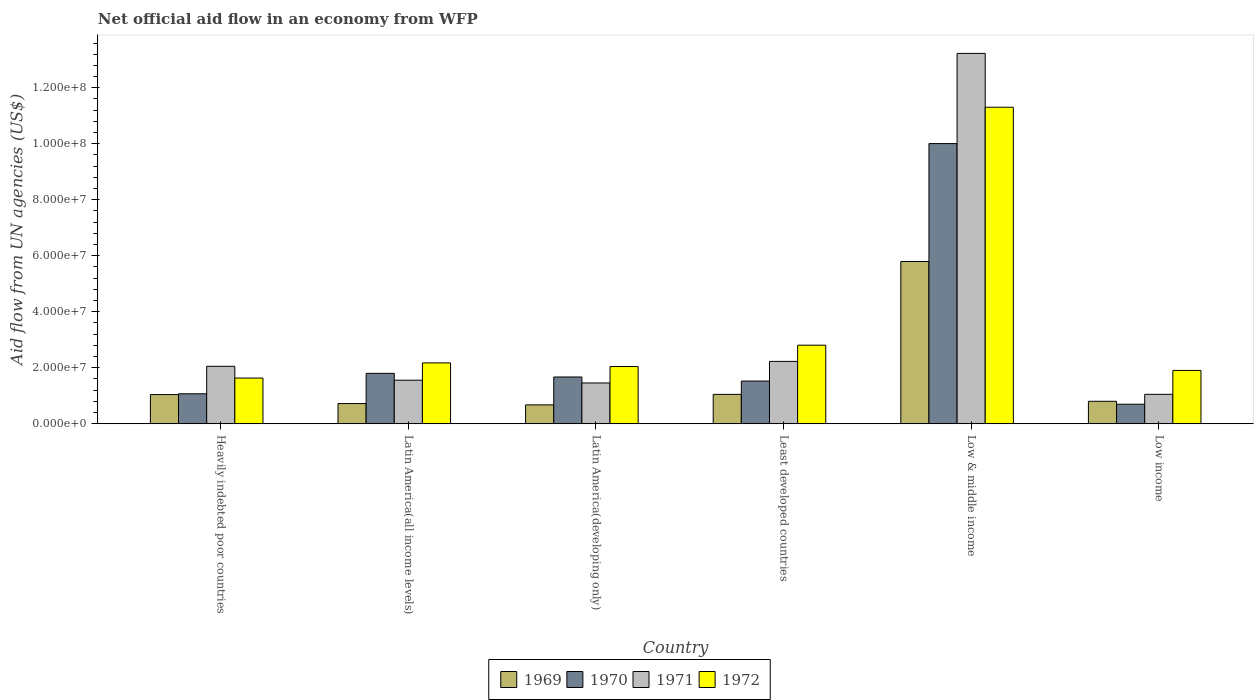Are the number of bars on each tick of the X-axis equal?
Offer a terse response. Yes. How many bars are there on the 2nd tick from the left?
Make the answer very short. 4. How many bars are there on the 4th tick from the right?
Provide a short and direct response. 4. What is the label of the 3rd group of bars from the left?
Ensure brevity in your answer.  Latin America(developing only). In how many cases, is the number of bars for a given country not equal to the number of legend labels?
Make the answer very short. 0. What is the net official aid flow in 1969 in Low & middle income?
Make the answer very short. 5.80e+07. Across all countries, what is the maximum net official aid flow in 1970?
Offer a very short reply. 1.00e+08. Across all countries, what is the minimum net official aid flow in 1972?
Offer a very short reply. 1.63e+07. What is the total net official aid flow in 1970 in the graph?
Give a very brief answer. 1.68e+08. What is the difference between the net official aid flow in 1969 in Heavily indebted poor countries and that in Latin America(all income levels)?
Provide a short and direct response. 3.21e+06. What is the difference between the net official aid flow in 1971 in Latin America(developing only) and the net official aid flow in 1972 in Latin America(all income levels)?
Your answer should be very brief. -7.17e+06. What is the average net official aid flow in 1972 per country?
Offer a very short reply. 3.64e+07. What is the difference between the net official aid flow of/in 1970 and net official aid flow of/in 1972 in Least developed countries?
Provide a succinct answer. -1.28e+07. In how many countries, is the net official aid flow in 1972 greater than 116000000 US$?
Keep it short and to the point. 0. What is the ratio of the net official aid flow in 1972 in Latin America(all income levels) to that in Low income?
Give a very brief answer. 1.14. What is the difference between the highest and the second highest net official aid flow in 1970?
Offer a very short reply. 8.34e+07. What is the difference between the highest and the lowest net official aid flow in 1969?
Your response must be concise. 5.12e+07. Is it the case that in every country, the sum of the net official aid flow in 1970 and net official aid flow in 1972 is greater than the sum of net official aid flow in 1969 and net official aid flow in 1971?
Your answer should be very brief. No. What does the 3rd bar from the left in Latin America(developing only) represents?
Give a very brief answer. 1971. What does the 4th bar from the right in Latin America(all income levels) represents?
Provide a short and direct response. 1969. How many bars are there?
Your answer should be very brief. 24. Are all the bars in the graph horizontal?
Your answer should be compact. No. What is the difference between two consecutive major ticks on the Y-axis?
Give a very brief answer. 2.00e+07. Are the values on the major ticks of Y-axis written in scientific E-notation?
Your response must be concise. Yes. Does the graph contain grids?
Offer a very short reply. No. What is the title of the graph?
Your response must be concise. Net official aid flow in an economy from WFP. Does "1971" appear as one of the legend labels in the graph?
Make the answer very short. Yes. What is the label or title of the Y-axis?
Make the answer very short. Aid flow from UN agencies (US$). What is the Aid flow from UN agencies (US$) of 1969 in Heavily indebted poor countries?
Provide a succinct answer. 1.04e+07. What is the Aid flow from UN agencies (US$) of 1970 in Heavily indebted poor countries?
Your response must be concise. 1.07e+07. What is the Aid flow from UN agencies (US$) in 1971 in Heavily indebted poor countries?
Your answer should be very brief. 2.05e+07. What is the Aid flow from UN agencies (US$) in 1972 in Heavily indebted poor countries?
Your answer should be compact. 1.63e+07. What is the Aid flow from UN agencies (US$) of 1969 in Latin America(all income levels)?
Your answer should be very brief. 7.21e+06. What is the Aid flow from UN agencies (US$) in 1970 in Latin America(all income levels)?
Provide a short and direct response. 1.80e+07. What is the Aid flow from UN agencies (US$) of 1971 in Latin America(all income levels)?
Offer a terse response. 1.56e+07. What is the Aid flow from UN agencies (US$) in 1972 in Latin America(all income levels)?
Give a very brief answer. 2.17e+07. What is the Aid flow from UN agencies (US$) in 1969 in Latin America(developing only)?
Your response must be concise. 6.74e+06. What is the Aid flow from UN agencies (US$) in 1970 in Latin America(developing only)?
Provide a succinct answer. 1.67e+07. What is the Aid flow from UN agencies (US$) of 1971 in Latin America(developing only)?
Make the answer very short. 1.46e+07. What is the Aid flow from UN agencies (US$) of 1972 in Latin America(developing only)?
Your answer should be very brief. 2.04e+07. What is the Aid flow from UN agencies (US$) of 1969 in Least developed countries?
Give a very brief answer. 1.05e+07. What is the Aid flow from UN agencies (US$) in 1970 in Least developed countries?
Ensure brevity in your answer.  1.52e+07. What is the Aid flow from UN agencies (US$) in 1971 in Least developed countries?
Your response must be concise. 2.23e+07. What is the Aid flow from UN agencies (US$) in 1972 in Least developed countries?
Provide a succinct answer. 2.81e+07. What is the Aid flow from UN agencies (US$) in 1969 in Low & middle income?
Your response must be concise. 5.80e+07. What is the Aid flow from UN agencies (US$) of 1970 in Low & middle income?
Your answer should be compact. 1.00e+08. What is the Aid flow from UN agencies (US$) in 1971 in Low & middle income?
Keep it short and to the point. 1.32e+08. What is the Aid flow from UN agencies (US$) in 1972 in Low & middle income?
Ensure brevity in your answer.  1.13e+08. What is the Aid flow from UN agencies (US$) in 1969 in Low income?
Give a very brief answer. 8.02e+06. What is the Aid flow from UN agencies (US$) of 1970 in Low income?
Ensure brevity in your answer.  6.97e+06. What is the Aid flow from UN agencies (US$) in 1971 in Low income?
Give a very brief answer. 1.05e+07. What is the Aid flow from UN agencies (US$) in 1972 in Low income?
Provide a short and direct response. 1.90e+07. Across all countries, what is the maximum Aid flow from UN agencies (US$) of 1969?
Give a very brief answer. 5.80e+07. Across all countries, what is the maximum Aid flow from UN agencies (US$) of 1970?
Ensure brevity in your answer.  1.00e+08. Across all countries, what is the maximum Aid flow from UN agencies (US$) in 1971?
Provide a short and direct response. 1.32e+08. Across all countries, what is the maximum Aid flow from UN agencies (US$) of 1972?
Offer a very short reply. 1.13e+08. Across all countries, what is the minimum Aid flow from UN agencies (US$) of 1969?
Your answer should be compact. 6.74e+06. Across all countries, what is the minimum Aid flow from UN agencies (US$) in 1970?
Offer a terse response. 6.97e+06. Across all countries, what is the minimum Aid flow from UN agencies (US$) in 1971?
Provide a succinct answer. 1.05e+07. Across all countries, what is the minimum Aid flow from UN agencies (US$) in 1972?
Offer a very short reply. 1.63e+07. What is the total Aid flow from UN agencies (US$) in 1969 in the graph?
Give a very brief answer. 1.01e+08. What is the total Aid flow from UN agencies (US$) of 1970 in the graph?
Your response must be concise. 1.68e+08. What is the total Aid flow from UN agencies (US$) in 1971 in the graph?
Your answer should be compact. 2.16e+08. What is the total Aid flow from UN agencies (US$) in 1972 in the graph?
Ensure brevity in your answer.  2.19e+08. What is the difference between the Aid flow from UN agencies (US$) of 1969 in Heavily indebted poor countries and that in Latin America(all income levels)?
Your response must be concise. 3.21e+06. What is the difference between the Aid flow from UN agencies (US$) of 1970 in Heavily indebted poor countries and that in Latin America(all income levels)?
Ensure brevity in your answer.  -7.30e+06. What is the difference between the Aid flow from UN agencies (US$) of 1971 in Heavily indebted poor countries and that in Latin America(all income levels)?
Ensure brevity in your answer.  4.97e+06. What is the difference between the Aid flow from UN agencies (US$) of 1972 in Heavily indebted poor countries and that in Latin America(all income levels)?
Provide a succinct answer. -5.41e+06. What is the difference between the Aid flow from UN agencies (US$) of 1969 in Heavily indebted poor countries and that in Latin America(developing only)?
Keep it short and to the point. 3.68e+06. What is the difference between the Aid flow from UN agencies (US$) of 1970 in Heavily indebted poor countries and that in Latin America(developing only)?
Your response must be concise. -6.00e+06. What is the difference between the Aid flow from UN agencies (US$) in 1971 in Heavily indebted poor countries and that in Latin America(developing only)?
Provide a succinct answer. 5.96e+06. What is the difference between the Aid flow from UN agencies (US$) in 1972 in Heavily indebted poor countries and that in Latin America(developing only)?
Your answer should be very brief. -4.11e+06. What is the difference between the Aid flow from UN agencies (US$) of 1969 in Heavily indebted poor countries and that in Least developed countries?
Give a very brief answer. -7.00e+04. What is the difference between the Aid flow from UN agencies (US$) in 1970 in Heavily indebted poor countries and that in Least developed countries?
Keep it short and to the point. -4.54e+06. What is the difference between the Aid flow from UN agencies (US$) in 1971 in Heavily indebted poor countries and that in Least developed countries?
Your response must be concise. -1.75e+06. What is the difference between the Aid flow from UN agencies (US$) of 1972 in Heavily indebted poor countries and that in Least developed countries?
Offer a terse response. -1.17e+07. What is the difference between the Aid flow from UN agencies (US$) of 1969 in Heavily indebted poor countries and that in Low & middle income?
Your answer should be very brief. -4.75e+07. What is the difference between the Aid flow from UN agencies (US$) of 1970 in Heavily indebted poor countries and that in Low & middle income?
Offer a very short reply. -8.94e+07. What is the difference between the Aid flow from UN agencies (US$) of 1971 in Heavily indebted poor countries and that in Low & middle income?
Give a very brief answer. -1.12e+08. What is the difference between the Aid flow from UN agencies (US$) of 1972 in Heavily indebted poor countries and that in Low & middle income?
Give a very brief answer. -9.67e+07. What is the difference between the Aid flow from UN agencies (US$) in 1969 in Heavily indebted poor countries and that in Low income?
Offer a terse response. 2.40e+06. What is the difference between the Aid flow from UN agencies (US$) of 1970 in Heavily indebted poor countries and that in Low income?
Give a very brief answer. 3.73e+06. What is the difference between the Aid flow from UN agencies (US$) in 1971 in Heavily indebted poor countries and that in Low income?
Provide a succinct answer. 1.00e+07. What is the difference between the Aid flow from UN agencies (US$) of 1972 in Heavily indebted poor countries and that in Low income?
Ensure brevity in your answer.  -2.72e+06. What is the difference between the Aid flow from UN agencies (US$) in 1969 in Latin America(all income levels) and that in Latin America(developing only)?
Make the answer very short. 4.70e+05. What is the difference between the Aid flow from UN agencies (US$) of 1970 in Latin America(all income levels) and that in Latin America(developing only)?
Offer a very short reply. 1.30e+06. What is the difference between the Aid flow from UN agencies (US$) of 1971 in Latin America(all income levels) and that in Latin America(developing only)?
Your answer should be very brief. 9.90e+05. What is the difference between the Aid flow from UN agencies (US$) in 1972 in Latin America(all income levels) and that in Latin America(developing only)?
Offer a very short reply. 1.30e+06. What is the difference between the Aid flow from UN agencies (US$) in 1969 in Latin America(all income levels) and that in Least developed countries?
Your answer should be compact. -3.28e+06. What is the difference between the Aid flow from UN agencies (US$) in 1970 in Latin America(all income levels) and that in Least developed countries?
Your answer should be compact. 2.76e+06. What is the difference between the Aid flow from UN agencies (US$) in 1971 in Latin America(all income levels) and that in Least developed countries?
Provide a succinct answer. -6.72e+06. What is the difference between the Aid flow from UN agencies (US$) of 1972 in Latin America(all income levels) and that in Least developed countries?
Offer a terse response. -6.33e+06. What is the difference between the Aid flow from UN agencies (US$) of 1969 in Latin America(all income levels) and that in Low & middle income?
Provide a succinct answer. -5.08e+07. What is the difference between the Aid flow from UN agencies (US$) of 1970 in Latin America(all income levels) and that in Low & middle income?
Provide a short and direct response. -8.21e+07. What is the difference between the Aid flow from UN agencies (US$) of 1971 in Latin America(all income levels) and that in Low & middle income?
Your answer should be compact. -1.17e+08. What is the difference between the Aid flow from UN agencies (US$) in 1972 in Latin America(all income levels) and that in Low & middle income?
Your answer should be compact. -9.13e+07. What is the difference between the Aid flow from UN agencies (US$) of 1969 in Latin America(all income levels) and that in Low income?
Keep it short and to the point. -8.10e+05. What is the difference between the Aid flow from UN agencies (US$) of 1970 in Latin America(all income levels) and that in Low income?
Your response must be concise. 1.10e+07. What is the difference between the Aid flow from UN agencies (US$) in 1971 in Latin America(all income levels) and that in Low income?
Keep it short and to the point. 5.04e+06. What is the difference between the Aid flow from UN agencies (US$) of 1972 in Latin America(all income levels) and that in Low income?
Offer a very short reply. 2.69e+06. What is the difference between the Aid flow from UN agencies (US$) of 1969 in Latin America(developing only) and that in Least developed countries?
Provide a short and direct response. -3.75e+06. What is the difference between the Aid flow from UN agencies (US$) of 1970 in Latin America(developing only) and that in Least developed countries?
Give a very brief answer. 1.46e+06. What is the difference between the Aid flow from UN agencies (US$) of 1971 in Latin America(developing only) and that in Least developed countries?
Provide a succinct answer. -7.71e+06. What is the difference between the Aid flow from UN agencies (US$) in 1972 in Latin America(developing only) and that in Least developed countries?
Provide a short and direct response. -7.63e+06. What is the difference between the Aid flow from UN agencies (US$) in 1969 in Latin America(developing only) and that in Low & middle income?
Offer a terse response. -5.12e+07. What is the difference between the Aid flow from UN agencies (US$) in 1970 in Latin America(developing only) and that in Low & middle income?
Provide a succinct answer. -8.34e+07. What is the difference between the Aid flow from UN agencies (US$) in 1971 in Latin America(developing only) and that in Low & middle income?
Make the answer very short. -1.18e+08. What is the difference between the Aid flow from UN agencies (US$) of 1972 in Latin America(developing only) and that in Low & middle income?
Your response must be concise. -9.26e+07. What is the difference between the Aid flow from UN agencies (US$) in 1969 in Latin America(developing only) and that in Low income?
Your answer should be very brief. -1.28e+06. What is the difference between the Aid flow from UN agencies (US$) in 1970 in Latin America(developing only) and that in Low income?
Your answer should be compact. 9.73e+06. What is the difference between the Aid flow from UN agencies (US$) in 1971 in Latin America(developing only) and that in Low income?
Keep it short and to the point. 4.05e+06. What is the difference between the Aid flow from UN agencies (US$) of 1972 in Latin America(developing only) and that in Low income?
Your answer should be very brief. 1.39e+06. What is the difference between the Aid flow from UN agencies (US$) in 1969 in Least developed countries and that in Low & middle income?
Your answer should be compact. -4.75e+07. What is the difference between the Aid flow from UN agencies (US$) in 1970 in Least developed countries and that in Low & middle income?
Your answer should be compact. -8.48e+07. What is the difference between the Aid flow from UN agencies (US$) of 1971 in Least developed countries and that in Low & middle income?
Ensure brevity in your answer.  -1.10e+08. What is the difference between the Aid flow from UN agencies (US$) in 1972 in Least developed countries and that in Low & middle income?
Ensure brevity in your answer.  -8.50e+07. What is the difference between the Aid flow from UN agencies (US$) in 1969 in Least developed countries and that in Low income?
Provide a succinct answer. 2.47e+06. What is the difference between the Aid flow from UN agencies (US$) of 1970 in Least developed countries and that in Low income?
Make the answer very short. 8.27e+06. What is the difference between the Aid flow from UN agencies (US$) in 1971 in Least developed countries and that in Low income?
Offer a terse response. 1.18e+07. What is the difference between the Aid flow from UN agencies (US$) in 1972 in Least developed countries and that in Low income?
Provide a short and direct response. 9.02e+06. What is the difference between the Aid flow from UN agencies (US$) of 1969 in Low & middle income and that in Low income?
Ensure brevity in your answer.  4.99e+07. What is the difference between the Aid flow from UN agencies (US$) in 1970 in Low & middle income and that in Low income?
Your response must be concise. 9.31e+07. What is the difference between the Aid flow from UN agencies (US$) in 1971 in Low & middle income and that in Low income?
Provide a succinct answer. 1.22e+08. What is the difference between the Aid flow from UN agencies (US$) of 1972 in Low & middle income and that in Low income?
Ensure brevity in your answer.  9.40e+07. What is the difference between the Aid flow from UN agencies (US$) in 1969 in Heavily indebted poor countries and the Aid flow from UN agencies (US$) in 1970 in Latin America(all income levels)?
Your answer should be very brief. -7.58e+06. What is the difference between the Aid flow from UN agencies (US$) of 1969 in Heavily indebted poor countries and the Aid flow from UN agencies (US$) of 1971 in Latin America(all income levels)?
Offer a terse response. -5.13e+06. What is the difference between the Aid flow from UN agencies (US$) in 1969 in Heavily indebted poor countries and the Aid flow from UN agencies (US$) in 1972 in Latin America(all income levels)?
Offer a terse response. -1.13e+07. What is the difference between the Aid flow from UN agencies (US$) of 1970 in Heavily indebted poor countries and the Aid flow from UN agencies (US$) of 1971 in Latin America(all income levels)?
Provide a short and direct response. -4.85e+06. What is the difference between the Aid flow from UN agencies (US$) of 1970 in Heavily indebted poor countries and the Aid flow from UN agencies (US$) of 1972 in Latin America(all income levels)?
Offer a very short reply. -1.10e+07. What is the difference between the Aid flow from UN agencies (US$) in 1971 in Heavily indebted poor countries and the Aid flow from UN agencies (US$) in 1972 in Latin America(all income levels)?
Offer a terse response. -1.21e+06. What is the difference between the Aid flow from UN agencies (US$) in 1969 in Heavily indebted poor countries and the Aid flow from UN agencies (US$) in 1970 in Latin America(developing only)?
Provide a succinct answer. -6.28e+06. What is the difference between the Aid flow from UN agencies (US$) of 1969 in Heavily indebted poor countries and the Aid flow from UN agencies (US$) of 1971 in Latin America(developing only)?
Provide a short and direct response. -4.14e+06. What is the difference between the Aid flow from UN agencies (US$) of 1969 in Heavily indebted poor countries and the Aid flow from UN agencies (US$) of 1972 in Latin America(developing only)?
Offer a terse response. -1.00e+07. What is the difference between the Aid flow from UN agencies (US$) of 1970 in Heavily indebted poor countries and the Aid flow from UN agencies (US$) of 1971 in Latin America(developing only)?
Your response must be concise. -3.86e+06. What is the difference between the Aid flow from UN agencies (US$) in 1970 in Heavily indebted poor countries and the Aid flow from UN agencies (US$) in 1972 in Latin America(developing only)?
Provide a succinct answer. -9.73e+06. What is the difference between the Aid flow from UN agencies (US$) in 1969 in Heavily indebted poor countries and the Aid flow from UN agencies (US$) in 1970 in Least developed countries?
Your answer should be compact. -4.82e+06. What is the difference between the Aid flow from UN agencies (US$) of 1969 in Heavily indebted poor countries and the Aid flow from UN agencies (US$) of 1971 in Least developed countries?
Provide a short and direct response. -1.18e+07. What is the difference between the Aid flow from UN agencies (US$) in 1969 in Heavily indebted poor countries and the Aid flow from UN agencies (US$) in 1972 in Least developed countries?
Keep it short and to the point. -1.76e+07. What is the difference between the Aid flow from UN agencies (US$) in 1970 in Heavily indebted poor countries and the Aid flow from UN agencies (US$) in 1971 in Least developed countries?
Offer a terse response. -1.16e+07. What is the difference between the Aid flow from UN agencies (US$) of 1970 in Heavily indebted poor countries and the Aid flow from UN agencies (US$) of 1972 in Least developed countries?
Your answer should be very brief. -1.74e+07. What is the difference between the Aid flow from UN agencies (US$) in 1971 in Heavily indebted poor countries and the Aid flow from UN agencies (US$) in 1972 in Least developed countries?
Provide a short and direct response. -7.54e+06. What is the difference between the Aid flow from UN agencies (US$) in 1969 in Heavily indebted poor countries and the Aid flow from UN agencies (US$) in 1970 in Low & middle income?
Your answer should be very brief. -8.96e+07. What is the difference between the Aid flow from UN agencies (US$) in 1969 in Heavily indebted poor countries and the Aid flow from UN agencies (US$) in 1971 in Low & middle income?
Your answer should be compact. -1.22e+08. What is the difference between the Aid flow from UN agencies (US$) in 1969 in Heavily indebted poor countries and the Aid flow from UN agencies (US$) in 1972 in Low & middle income?
Keep it short and to the point. -1.03e+08. What is the difference between the Aid flow from UN agencies (US$) of 1970 in Heavily indebted poor countries and the Aid flow from UN agencies (US$) of 1971 in Low & middle income?
Your answer should be very brief. -1.22e+08. What is the difference between the Aid flow from UN agencies (US$) of 1970 in Heavily indebted poor countries and the Aid flow from UN agencies (US$) of 1972 in Low & middle income?
Offer a terse response. -1.02e+08. What is the difference between the Aid flow from UN agencies (US$) in 1971 in Heavily indebted poor countries and the Aid flow from UN agencies (US$) in 1972 in Low & middle income?
Offer a terse response. -9.25e+07. What is the difference between the Aid flow from UN agencies (US$) of 1969 in Heavily indebted poor countries and the Aid flow from UN agencies (US$) of 1970 in Low income?
Ensure brevity in your answer.  3.45e+06. What is the difference between the Aid flow from UN agencies (US$) in 1969 in Heavily indebted poor countries and the Aid flow from UN agencies (US$) in 1971 in Low income?
Provide a short and direct response. -9.00e+04. What is the difference between the Aid flow from UN agencies (US$) of 1969 in Heavily indebted poor countries and the Aid flow from UN agencies (US$) of 1972 in Low income?
Ensure brevity in your answer.  -8.62e+06. What is the difference between the Aid flow from UN agencies (US$) in 1970 in Heavily indebted poor countries and the Aid flow from UN agencies (US$) in 1971 in Low income?
Your response must be concise. 1.90e+05. What is the difference between the Aid flow from UN agencies (US$) in 1970 in Heavily indebted poor countries and the Aid flow from UN agencies (US$) in 1972 in Low income?
Provide a succinct answer. -8.34e+06. What is the difference between the Aid flow from UN agencies (US$) of 1971 in Heavily indebted poor countries and the Aid flow from UN agencies (US$) of 1972 in Low income?
Provide a short and direct response. 1.48e+06. What is the difference between the Aid flow from UN agencies (US$) of 1969 in Latin America(all income levels) and the Aid flow from UN agencies (US$) of 1970 in Latin America(developing only)?
Make the answer very short. -9.49e+06. What is the difference between the Aid flow from UN agencies (US$) in 1969 in Latin America(all income levels) and the Aid flow from UN agencies (US$) in 1971 in Latin America(developing only)?
Your answer should be very brief. -7.35e+06. What is the difference between the Aid flow from UN agencies (US$) of 1969 in Latin America(all income levels) and the Aid flow from UN agencies (US$) of 1972 in Latin America(developing only)?
Give a very brief answer. -1.32e+07. What is the difference between the Aid flow from UN agencies (US$) of 1970 in Latin America(all income levels) and the Aid flow from UN agencies (US$) of 1971 in Latin America(developing only)?
Provide a succinct answer. 3.44e+06. What is the difference between the Aid flow from UN agencies (US$) of 1970 in Latin America(all income levels) and the Aid flow from UN agencies (US$) of 1972 in Latin America(developing only)?
Keep it short and to the point. -2.43e+06. What is the difference between the Aid flow from UN agencies (US$) of 1971 in Latin America(all income levels) and the Aid flow from UN agencies (US$) of 1972 in Latin America(developing only)?
Give a very brief answer. -4.88e+06. What is the difference between the Aid flow from UN agencies (US$) in 1969 in Latin America(all income levels) and the Aid flow from UN agencies (US$) in 1970 in Least developed countries?
Offer a very short reply. -8.03e+06. What is the difference between the Aid flow from UN agencies (US$) of 1969 in Latin America(all income levels) and the Aid flow from UN agencies (US$) of 1971 in Least developed countries?
Your answer should be very brief. -1.51e+07. What is the difference between the Aid flow from UN agencies (US$) in 1969 in Latin America(all income levels) and the Aid flow from UN agencies (US$) in 1972 in Least developed countries?
Make the answer very short. -2.08e+07. What is the difference between the Aid flow from UN agencies (US$) in 1970 in Latin America(all income levels) and the Aid flow from UN agencies (US$) in 1971 in Least developed countries?
Offer a terse response. -4.27e+06. What is the difference between the Aid flow from UN agencies (US$) of 1970 in Latin America(all income levels) and the Aid flow from UN agencies (US$) of 1972 in Least developed countries?
Offer a terse response. -1.01e+07. What is the difference between the Aid flow from UN agencies (US$) in 1971 in Latin America(all income levels) and the Aid flow from UN agencies (US$) in 1972 in Least developed countries?
Offer a terse response. -1.25e+07. What is the difference between the Aid flow from UN agencies (US$) of 1969 in Latin America(all income levels) and the Aid flow from UN agencies (US$) of 1970 in Low & middle income?
Your answer should be compact. -9.29e+07. What is the difference between the Aid flow from UN agencies (US$) of 1969 in Latin America(all income levels) and the Aid flow from UN agencies (US$) of 1971 in Low & middle income?
Your response must be concise. -1.25e+08. What is the difference between the Aid flow from UN agencies (US$) in 1969 in Latin America(all income levels) and the Aid flow from UN agencies (US$) in 1972 in Low & middle income?
Offer a very short reply. -1.06e+08. What is the difference between the Aid flow from UN agencies (US$) of 1970 in Latin America(all income levels) and the Aid flow from UN agencies (US$) of 1971 in Low & middle income?
Offer a very short reply. -1.14e+08. What is the difference between the Aid flow from UN agencies (US$) in 1970 in Latin America(all income levels) and the Aid flow from UN agencies (US$) in 1972 in Low & middle income?
Provide a succinct answer. -9.51e+07. What is the difference between the Aid flow from UN agencies (US$) of 1971 in Latin America(all income levels) and the Aid flow from UN agencies (US$) of 1972 in Low & middle income?
Your response must be concise. -9.75e+07. What is the difference between the Aid flow from UN agencies (US$) of 1969 in Latin America(all income levels) and the Aid flow from UN agencies (US$) of 1971 in Low income?
Your answer should be compact. -3.30e+06. What is the difference between the Aid flow from UN agencies (US$) in 1969 in Latin America(all income levels) and the Aid flow from UN agencies (US$) in 1972 in Low income?
Offer a very short reply. -1.18e+07. What is the difference between the Aid flow from UN agencies (US$) of 1970 in Latin America(all income levels) and the Aid flow from UN agencies (US$) of 1971 in Low income?
Offer a terse response. 7.49e+06. What is the difference between the Aid flow from UN agencies (US$) of 1970 in Latin America(all income levels) and the Aid flow from UN agencies (US$) of 1972 in Low income?
Keep it short and to the point. -1.04e+06. What is the difference between the Aid flow from UN agencies (US$) of 1971 in Latin America(all income levels) and the Aid flow from UN agencies (US$) of 1972 in Low income?
Keep it short and to the point. -3.49e+06. What is the difference between the Aid flow from UN agencies (US$) of 1969 in Latin America(developing only) and the Aid flow from UN agencies (US$) of 1970 in Least developed countries?
Give a very brief answer. -8.50e+06. What is the difference between the Aid flow from UN agencies (US$) in 1969 in Latin America(developing only) and the Aid flow from UN agencies (US$) in 1971 in Least developed countries?
Provide a succinct answer. -1.55e+07. What is the difference between the Aid flow from UN agencies (US$) in 1969 in Latin America(developing only) and the Aid flow from UN agencies (US$) in 1972 in Least developed countries?
Provide a short and direct response. -2.13e+07. What is the difference between the Aid flow from UN agencies (US$) in 1970 in Latin America(developing only) and the Aid flow from UN agencies (US$) in 1971 in Least developed countries?
Your answer should be very brief. -5.57e+06. What is the difference between the Aid flow from UN agencies (US$) in 1970 in Latin America(developing only) and the Aid flow from UN agencies (US$) in 1972 in Least developed countries?
Give a very brief answer. -1.14e+07. What is the difference between the Aid flow from UN agencies (US$) in 1971 in Latin America(developing only) and the Aid flow from UN agencies (US$) in 1972 in Least developed countries?
Your answer should be compact. -1.35e+07. What is the difference between the Aid flow from UN agencies (US$) of 1969 in Latin America(developing only) and the Aid flow from UN agencies (US$) of 1970 in Low & middle income?
Offer a terse response. -9.33e+07. What is the difference between the Aid flow from UN agencies (US$) in 1969 in Latin America(developing only) and the Aid flow from UN agencies (US$) in 1971 in Low & middle income?
Provide a succinct answer. -1.26e+08. What is the difference between the Aid flow from UN agencies (US$) in 1969 in Latin America(developing only) and the Aid flow from UN agencies (US$) in 1972 in Low & middle income?
Your response must be concise. -1.06e+08. What is the difference between the Aid flow from UN agencies (US$) in 1970 in Latin America(developing only) and the Aid flow from UN agencies (US$) in 1971 in Low & middle income?
Your answer should be compact. -1.16e+08. What is the difference between the Aid flow from UN agencies (US$) of 1970 in Latin America(developing only) and the Aid flow from UN agencies (US$) of 1972 in Low & middle income?
Offer a very short reply. -9.64e+07. What is the difference between the Aid flow from UN agencies (US$) in 1971 in Latin America(developing only) and the Aid flow from UN agencies (US$) in 1972 in Low & middle income?
Give a very brief answer. -9.85e+07. What is the difference between the Aid flow from UN agencies (US$) of 1969 in Latin America(developing only) and the Aid flow from UN agencies (US$) of 1970 in Low income?
Ensure brevity in your answer.  -2.30e+05. What is the difference between the Aid flow from UN agencies (US$) of 1969 in Latin America(developing only) and the Aid flow from UN agencies (US$) of 1971 in Low income?
Provide a succinct answer. -3.77e+06. What is the difference between the Aid flow from UN agencies (US$) in 1969 in Latin America(developing only) and the Aid flow from UN agencies (US$) in 1972 in Low income?
Your response must be concise. -1.23e+07. What is the difference between the Aid flow from UN agencies (US$) of 1970 in Latin America(developing only) and the Aid flow from UN agencies (US$) of 1971 in Low income?
Provide a succinct answer. 6.19e+06. What is the difference between the Aid flow from UN agencies (US$) of 1970 in Latin America(developing only) and the Aid flow from UN agencies (US$) of 1972 in Low income?
Your answer should be very brief. -2.34e+06. What is the difference between the Aid flow from UN agencies (US$) of 1971 in Latin America(developing only) and the Aid flow from UN agencies (US$) of 1972 in Low income?
Offer a very short reply. -4.48e+06. What is the difference between the Aid flow from UN agencies (US$) in 1969 in Least developed countries and the Aid flow from UN agencies (US$) in 1970 in Low & middle income?
Your answer should be very brief. -8.96e+07. What is the difference between the Aid flow from UN agencies (US$) in 1969 in Least developed countries and the Aid flow from UN agencies (US$) in 1971 in Low & middle income?
Make the answer very short. -1.22e+08. What is the difference between the Aid flow from UN agencies (US$) in 1969 in Least developed countries and the Aid flow from UN agencies (US$) in 1972 in Low & middle income?
Give a very brief answer. -1.03e+08. What is the difference between the Aid flow from UN agencies (US$) of 1970 in Least developed countries and the Aid flow from UN agencies (US$) of 1971 in Low & middle income?
Your response must be concise. -1.17e+08. What is the difference between the Aid flow from UN agencies (US$) in 1970 in Least developed countries and the Aid flow from UN agencies (US$) in 1972 in Low & middle income?
Provide a succinct answer. -9.78e+07. What is the difference between the Aid flow from UN agencies (US$) in 1971 in Least developed countries and the Aid flow from UN agencies (US$) in 1972 in Low & middle income?
Your answer should be very brief. -9.08e+07. What is the difference between the Aid flow from UN agencies (US$) of 1969 in Least developed countries and the Aid flow from UN agencies (US$) of 1970 in Low income?
Give a very brief answer. 3.52e+06. What is the difference between the Aid flow from UN agencies (US$) in 1969 in Least developed countries and the Aid flow from UN agencies (US$) in 1971 in Low income?
Your answer should be compact. -2.00e+04. What is the difference between the Aid flow from UN agencies (US$) in 1969 in Least developed countries and the Aid flow from UN agencies (US$) in 1972 in Low income?
Your answer should be compact. -8.55e+06. What is the difference between the Aid flow from UN agencies (US$) of 1970 in Least developed countries and the Aid flow from UN agencies (US$) of 1971 in Low income?
Keep it short and to the point. 4.73e+06. What is the difference between the Aid flow from UN agencies (US$) in 1970 in Least developed countries and the Aid flow from UN agencies (US$) in 1972 in Low income?
Offer a terse response. -3.80e+06. What is the difference between the Aid flow from UN agencies (US$) in 1971 in Least developed countries and the Aid flow from UN agencies (US$) in 1972 in Low income?
Offer a terse response. 3.23e+06. What is the difference between the Aid flow from UN agencies (US$) in 1969 in Low & middle income and the Aid flow from UN agencies (US$) in 1970 in Low income?
Offer a very short reply. 5.10e+07. What is the difference between the Aid flow from UN agencies (US$) of 1969 in Low & middle income and the Aid flow from UN agencies (US$) of 1971 in Low income?
Provide a succinct answer. 4.74e+07. What is the difference between the Aid flow from UN agencies (US$) in 1969 in Low & middle income and the Aid flow from UN agencies (US$) in 1972 in Low income?
Your answer should be compact. 3.89e+07. What is the difference between the Aid flow from UN agencies (US$) in 1970 in Low & middle income and the Aid flow from UN agencies (US$) in 1971 in Low income?
Give a very brief answer. 8.96e+07. What is the difference between the Aid flow from UN agencies (US$) of 1970 in Low & middle income and the Aid flow from UN agencies (US$) of 1972 in Low income?
Your answer should be very brief. 8.10e+07. What is the difference between the Aid flow from UN agencies (US$) of 1971 in Low & middle income and the Aid flow from UN agencies (US$) of 1972 in Low income?
Ensure brevity in your answer.  1.13e+08. What is the average Aid flow from UN agencies (US$) in 1969 per country?
Ensure brevity in your answer.  1.68e+07. What is the average Aid flow from UN agencies (US$) in 1970 per country?
Give a very brief answer. 2.79e+07. What is the average Aid flow from UN agencies (US$) in 1971 per country?
Provide a succinct answer. 3.60e+07. What is the average Aid flow from UN agencies (US$) in 1972 per country?
Ensure brevity in your answer.  3.64e+07. What is the difference between the Aid flow from UN agencies (US$) of 1969 and Aid flow from UN agencies (US$) of 1970 in Heavily indebted poor countries?
Your response must be concise. -2.80e+05. What is the difference between the Aid flow from UN agencies (US$) of 1969 and Aid flow from UN agencies (US$) of 1971 in Heavily indebted poor countries?
Your response must be concise. -1.01e+07. What is the difference between the Aid flow from UN agencies (US$) of 1969 and Aid flow from UN agencies (US$) of 1972 in Heavily indebted poor countries?
Ensure brevity in your answer.  -5.90e+06. What is the difference between the Aid flow from UN agencies (US$) in 1970 and Aid flow from UN agencies (US$) in 1971 in Heavily indebted poor countries?
Your answer should be very brief. -9.82e+06. What is the difference between the Aid flow from UN agencies (US$) of 1970 and Aid flow from UN agencies (US$) of 1972 in Heavily indebted poor countries?
Provide a succinct answer. -5.62e+06. What is the difference between the Aid flow from UN agencies (US$) in 1971 and Aid flow from UN agencies (US$) in 1972 in Heavily indebted poor countries?
Offer a terse response. 4.20e+06. What is the difference between the Aid flow from UN agencies (US$) of 1969 and Aid flow from UN agencies (US$) of 1970 in Latin America(all income levels)?
Provide a short and direct response. -1.08e+07. What is the difference between the Aid flow from UN agencies (US$) of 1969 and Aid flow from UN agencies (US$) of 1971 in Latin America(all income levels)?
Give a very brief answer. -8.34e+06. What is the difference between the Aid flow from UN agencies (US$) of 1969 and Aid flow from UN agencies (US$) of 1972 in Latin America(all income levels)?
Offer a very short reply. -1.45e+07. What is the difference between the Aid flow from UN agencies (US$) in 1970 and Aid flow from UN agencies (US$) in 1971 in Latin America(all income levels)?
Give a very brief answer. 2.45e+06. What is the difference between the Aid flow from UN agencies (US$) in 1970 and Aid flow from UN agencies (US$) in 1972 in Latin America(all income levels)?
Offer a very short reply. -3.73e+06. What is the difference between the Aid flow from UN agencies (US$) in 1971 and Aid flow from UN agencies (US$) in 1972 in Latin America(all income levels)?
Your answer should be very brief. -6.18e+06. What is the difference between the Aid flow from UN agencies (US$) in 1969 and Aid flow from UN agencies (US$) in 1970 in Latin America(developing only)?
Ensure brevity in your answer.  -9.96e+06. What is the difference between the Aid flow from UN agencies (US$) of 1969 and Aid flow from UN agencies (US$) of 1971 in Latin America(developing only)?
Make the answer very short. -7.82e+06. What is the difference between the Aid flow from UN agencies (US$) of 1969 and Aid flow from UN agencies (US$) of 1972 in Latin America(developing only)?
Provide a short and direct response. -1.37e+07. What is the difference between the Aid flow from UN agencies (US$) of 1970 and Aid flow from UN agencies (US$) of 1971 in Latin America(developing only)?
Your answer should be compact. 2.14e+06. What is the difference between the Aid flow from UN agencies (US$) of 1970 and Aid flow from UN agencies (US$) of 1972 in Latin America(developing only)?
Ensure brevity in your answer.  -3.73e+06. What is the difference between the Aid flow from UN agencies (US$) in 1971 and Aid flow from UN agencies (US$) in 1972 in Latin America(developing only)?
Provide a short and direct response. -5.87e+06. What is the difference between the Aid flow from UN agencies (US$) of 1969 and Aid flow from UN agencies (US$) of 1970 in Least developed countries?
Your answer should be very brief. -4.75e+06. What is the difference between the Aid flow from UN agencies (US$) of 1969 and Aid flow from UN agencies (US$) of 1971 in Least developed countries?
Keep it short and to the point. -1.18e+07. What is the difference between the Aid flow from UN agencies (US$) of 1969 and Aid flow from UN agencies (US$) of 1972 in Least developed countries?
Keep it short and to the point. -1.76e+07. What is the difference between the Aid flow from UN agencies (US$) in 1970 and Aid flow from UN agencies (US$) in 1971 in Least developed countries?
Keep it short and to the point. -7.03e+06. What is the difference between the Aid flow from UN agencies (US$) of 1970 and Aid flow from UN agencies (US$) of 1972 in Least developed countries?
Offer a terse response. -1.28e+07. What is the difference between the Aid flow from UN agencies (US$) in 1971 and Aid flow from UN agencies (US$) in 1972 in Least developed countries?
Offer a very short reply. -5.79e+06. What is the difference between the Aid flow from UN agencies (US$) of 1969 and Aid flow from UN agencies (US$) of 1970 in Low & middle income?
Your response must be concise. -4.21e+07. What is the difference between the Aid flow from UN agencies (US$) in 1969 and Aid flow from UN agencies (US$) in 1971 in Low & middle income?
Your answer should be compact. -7.43e+07. What is the difference between the Aid flow from UN agencies (US$) of 1969 and Aid flow from UN agencies (US$) of 1972 in Low & middle income?
Offer a terse response. -5.51e+07. What is the difference between the Aid flow from UN agencies (US$) of 1970 and Aid flow from UN agencies (US$) of 1971 in Low & middle income?
Give a very brief answer. -3.22e+07. What is the difference between the Aid flow from UN agencies (US$) of 1970 and Aid flow from UN agencies (US$) of 1972 in Low & middle income?
Provide a short and direct response. -1.30e+07. What is the difference between the Aid flow from UN agencies (US$) of 1971 and Aid flow from UN agencies (US$) of 1972 in Low & middle income?
Your response must be concise. 1.92e+07. What is the difference between the Aid flow from UN agencies (US$) in 1969 and Aid flow from UN agencies (US$) in 1970 in Low income?
Give a very brief answer. 1.05e+06. What is the difference between the Aid flow from UN agencies (US$) in 1969 and Aid flow from UN agencies (US$) in 1971 in Low income?
Provide a succinct answer. -2.49e+06. What is the difference between the Aid flow from UN agencies (US$) of 1969 and Aid flow from UN agencies (US$) of 1972 in Low income?
Your answer should be very brief. -1.10e+07. What is the difference between the Aid flow from UN agencies (US$) in 1970 and Aid flow from UN agencies (US$) in 1971 in Low income?
Offer a terse response. -3.54e+06. What is the difference between the Aid flow from UN agencies (US$) in 1970 and Aid flow from UN agencies (US$) in 1972 in Low income?
Offer a very short reply. -1.21e+07. What is the difference between the Aid flow from UN agencies (US$) of 1971 and Aid flow from UN agencies (US$) of 1972 in Low income?
Your answer should be very brief. -8.53e+06. What is the ratio of the Aid flow from UN agencies (US$) of 1969 in Heavily indebted poor countries to that in Latin America(all income levels)?
Keep it short and to the point. 1.45. What is the ratio of the Aid flow from UN agencies (US$) of 1970 in Heavily indebted poor countries to that in Latin America(all income levels)?
Give a very brief answer. 0.59. What is the ratio of the Aid flow from UN agencies (US$) of 1971 in Heavily indebted poor countries to that in Latin America(all income levels)?
Provide a short and direct response. 1.32. What is the ratio of the Aid flow from UN agencies (US$) of 1972 in Heavily indebted poor countries to that in Latin America(all income levels)?
Make the answer very short. 0.75. What is the ratio of the Aid flow from UN agencies (US$) of 1969 in Heavily indebted poor countries to that in Latin America(developing only)?
Keep it short and to the point. 1.55. What is the ratio of the Aid flow from UN agencies (US$) of 1970 in Heavily indebted poor countries to that in Latin America(developing only)?
Your answer should be compact. 0.64. What is the ratio of the Aid flow from UN agencies (US$) in 1971 in Heavily indebted poor countries to that in Latin America(developing only)?
Give a very brief answer. 1.41. What is the ratio of the Aid flow from UN agencies (US$) of 1972 in Heavily indebted poor countries to that in Latin America(developing only)?
Offer a very short reply. 0.8. What is the ratio of the Aid flow from UN agencies (US$) in 1970 in Heavily indebted poor countries to that in Least developed countries?
Make the answer very short. 0.7. What is the ratio of the Aid flow from UN agencies (US$) in 1971 in Heavily indebted poor countries to that in Least developed countries?
Give a very brief answer. 0.92. What is the ratio of the Aid flow from UN agencies (US$) of 1972 in Heavily indebted poor countries to that in Least developed countries?
Keep it short and to the point. 0.58. What is the ratio of the Aid flow from UN agencies (US$) in 1969 in Heavily indebted poor countries to that in Low & middle income?
Your response must be concise. 0.18. What is the ratio of the Aid flow from UN agencies (US$) of 1970 in Heavily indebted poor countries to that in Low & middle income?
Ensure brevity in your answer.  0.11. What is the ratio of the Aid flow from UN agencies (US$) of 1971 in Heavily indebted poor countries to that in Low & middle income?
Your response must be concise. 0.16. What is the ratio of the Aid flow from UN agencies (US$) in 1972 in Heavily indebted poor countries to that in Low & middle income?
Offer a terse response. 0.14. What is the ratio of the Aid flow from UN agencies (US$) in 1969 in Heavily indebted poor countries to that in Low income?
Offer a terse response. 1.3. What is the ratio of the Aid flow from UN agencies (US$) in 1970 in Heavily indebted poor countries to that in Low income?
Make the answer very short. 1.54. What is the ratio of the Aid flow from UN agencies (US$) in 1971 in Heavily indebted poor countries to that in Low income?
Make the answer very short. 1.95. What is the ratio of the Aid flow from UN agencies (US$) in 1969 in Latin America(all income levels) to that in Latin America(developing only)?
Your answer should be very brief. 1.07. What is the ratio of the Aid flow from UN agencies (US$) in 1970 in Latin America(all income levels) to that in Latin America(developing only)?
Provide a short and direct response. 1.08. What is the ratio of the Aid flow from UN agencies (US$) of 1971 in Latin America(all income levels) to that in Latin America(developing only)?
Offer a very short reply. 1.07. What is the ratio of the Aid flow from UN agencies (US$) in 1972 in Latin America(all income levels) to that in Latin America(developing only)?
Provide a short and direct response. 1.06. What is the ratio of the Aid flow from UN agencies (US$) in 1969 in Latin America(all income levels) to that in Least developed countries?
Your answer should be very brief. 0.69. What is the ratio of the Aid flow from UN agencies (US$) of 1970 in Latin America(all income levels) to that in Least developed countries?
Provide a short and direct response. 1.18. What is the ratio of the Aid flow from UN agencies (US$) of 1971 in Latin America(all income levels) to that in Least developed countries?
Your answer should be very brief. 0.7. What is the ratio of the Aid flow from UN agencies (US$) of 1972 in Latin America(all income levels) to that in Least developed countries?
Your response must be concise. 0.77. What is the ratio of the Aid flow from UN agencies (US$) of 1969 in Latin America(all income levels) to that in Low & middle income?
Give a very brief answer. 0.12. What is the ratio of the Aid flow from UN agencies (US$) in 1970 in Latin America(all income levels) to that in Low & middle income?
Your answer should be very brief. 0.18. What is the ratio of the Aid flow from UN agencies (US$) in 1971 in Latin America(all income levels) to that in Low & middle income?
Your response must be concise. 0.12. What is the ratio of the Aid flow from UN agencies (US$) of 1972 in Latin America(all income levels) to that in Low & middle income?
Provide a short and direct response. 0.19. What is the ratio of the Aid flow from UN agencies (US$) of 1969 in Latin America(all income levels) to that in Low income?
Provide a succinct answer. 0.9. What is the ratio of the Aid flow from UN agencies (US$) of 1970 in Latin America(all income levels) to that in Low income?
Your answer should be compact. 2.58. What is the ratio of the Aid flow from UN agencies (US$) of 1971 in Latin America(all income levels) to that in Low income?
Keep it short and to the point. 1.48. What is the ratio of the Aid flow from UN agencies (US$) in 1972 in Latin America(all income levels) to that in Low income?
Your answer should be compact. 1.14. What is the ratio of the Aid flow from UN agencies (US$) of 1969 in Latin America(developing only) to that in Least developed countries?
Ensure brevity in your answer.  0.64. What is the ratio of the Aid flow from UN agencies (US$) of 1970 in Latin America(developing only) to that in Least developed countries?
Your response must be concise. 1.1. What is the ratio of the Aid flow from UN agencies (US$) in 1971 in Latin America(developing only) to that in Least developed countries?
Make the answer very short. 0.65. What is the ratio of the Aid flow from UN agencies (US$) of 1972 in Latin America(developing only) to that in Least developed countries?
Offer a very short reply. 0.73. What is the ratio of the Aid flow from UN agencies (US$) in 1969 in Latin America(developing only) to that in Low & middle income?
Offer a terse response. 0.12. What is the ratio of the Aid flow from UN agencies (US$) in 1970 in Latin America(developing only) to that in Low & middle income?
Ensure brevity in your answer.  0.17. What is the ratio of the Aid flow from UN agencies (US$) in 1971 in Latin America(developing only) to that in Low & middle income?
Your answer should be very brief. 0.11. What is the ratio of the Aid flow from UN agencies (US$) of 1972 in Latin America(developing only) to that in Low & middle income?
Ensure brevity in your answer.  0.18. What is the ratio of the Aid flow from UN agencies (US$) in 1969 in Latin America(developing only) to that in Low income?
Give a very brief answer. 0.84. What is the ratio of the Aid flow from UN agencies (US$) in 1970 in Latin America(developing only) to that in Low income?
Your answer should be compact. 2.4. What is the ratio of the Aid flow from UN agencies (US$) of 1971 in Latin America(developing only) to that in Low income?
Offer a very short reply. 1.39. What is the ratio of the Aid flow from UN agencies (US$) in 1972 in Latin America(developing only) to that in Low income?
Offer a very short reply. 1.07. What is the ratio of the Aid flow from UN agencies (US$) of 1969 in Least developed countries to that in Low & middle income?
Offer a terse response. 0.18. What is the ratio of the Aid flow from UN agencies (US$) of 1970 in Least developed countries to that in Low & middle income?
Give a very brief answer. 0.15. What is the ratio of the Aid flow from UN agencies (US$) of 1971 in Least developed countries to that in Low & middle income?
Offer a terse response. 0.17. What is the ratio of the Aid flow from UN agencies (US$) of 1972 in Least developed countries to that in Low & middle income?
Provide a short and direct response. 0.25. What is the ratio of the Aid flow from UN agencies (US$) in 1969 in Least developed countries to that in Low income?
Your answer should be compact. 1.31. What is the ratio of the Aid flow from UN agencies (US$) of 1970 in Least developed countries to that in Low income?
Make the answer very short. 2.19. What is the ratio of the Aid flow from UN agencies (US$) in 1971 in Least developed countries to that in Low income?
Make the answer very short. 2.12. What is the ratio of the Aid flow from UN agencies (US$) in 1972 in Least developed countries to that in Low income?
Offer a terse response. 1.47. What is the ratio of the Aid flow from UN agencies (US$) of 1969 in Low & middle income to that in Low income?
Make the answer very short. 7.23. What is the ratio of the Aid flow from UN agencies (US$) of 1970 in Low & middle income to that in Low income?
Keep it short and to the point. 14.36. What is the ratio of the Aid flow from UN agencies (US$) in 1971 in Low & middle income to that in Low income?
Make the answer very short. 12.59. What is the ratio of the Aid flow from UN agencies (US$) of 1972 in Low & middle income to that in Low income?
Keep it short and to the point. 5.94. What is the difference between the highest and the second highest Aid flow from UN agencies (US$) of 1969?
Offer a terse response. 4.75e+07. What is the difference between the highest and the second highest Aid flow from UN agencies (US$) in 1970?
Provide a succinct answer. 8.21e+07. What is the difference between the highest and the second highest Aid flow from UN agencies (US$) of 1971?
Your answer should be compact. 1.10e+08. What is the difference between the highest and the second highest Aid flow from UN agencies (US$) of 1972?
Your answer should be very brief. 8.50e+07. What is the difference between the highest and the lowest Aid flow from UN agencies (US$) of 1969?
Ensure brevity in your answer.  5.12e+07. What is the difference between the highest and the lowest Aid flow from UN agencies (US$) of 1970?
Give a very brief answer. 9.31e+07. What is the difference between the highest and the lowest Aid flow from UN agencies (US$) of 1971?
Ensure brevity in your answer.  1.22e+08. What is the difference between the highest and the lowest Aid flow from UN agencies (US$) of 1972?
Offer a very short reply. 9.67e+07. 